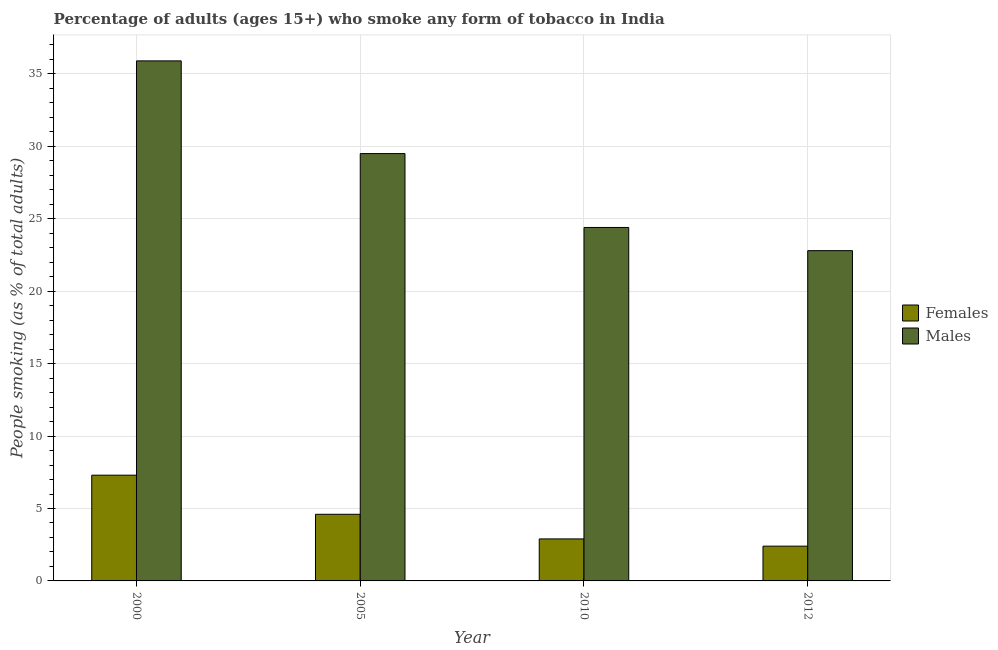How many bars are there on the 3rd tick from the left?
Make the answer very short. 2. In how many cases, is the number of bars for a given year not equal to the number of legend labels?
Offer a terse response. 0. What is the percentage of males who smoke in 2005?
Make the answer very short. 29.5. Across all years, what is the maximum percentage of males who smoke?
Provide a succinct answer. 35.9. Across all years, what is the minimum percentage of males who smoke?
Ensure brevity in your answer.  22.8. In which year was the percentage of males who smoke maximum?
Your answer should be very brief. 2000. What is the total percentage of females who smoke in the graph?
Your answer should be very brief. 17.2. What is the difference between the percentage of males who smoke in 2005 and the percentage of females who smoke in 2012?
Your response must be concise. 6.7. What is the average percentage of females who smoke per year?
Your answer should be compact. 4.3. In the year 2010, what is the difference between the percentage of females who smoke and percentage of males who smoke?
Provide a short and direct response. 0. What is the ratio of the percentage of females who smoke in 2000 to that in 2010?
Your answer should be compact. 2.52. Is the percentage of females who smoke in 2000 less than that in 2010?
Ensure brevity in your answer.  No. Is the difference between the percentage of males who smoke in 2005 and 2012 greater than the difference between the percentage of females who smoke in 2005 and 2012?
Offer a terse response. No. What is the difference between the highest and the second highest percentage of males who smoke?
Your response must be concise. 6.4. What is the difference between the highest and the lowest percentage of males who smoke?
Provide a short and direct response. 13.1. In how many years, is the percentage of females who smoke greater than the average percentage of females who smoke taken over all years?
Ensure brevity in your answer.  2. Is the sum of the percentage of males who smoke in 2000 and 2005 greater than the maximum percentage of females who smoke across all years?
Keep it short and to the point. Yes. What does the 1st bar from the left in 2005 represents?
Make the answer very short. Females. What does the 1st bar from the right in 2010 represents?
Your response must be concise. Males. How many bars are there?
Offer a very short reply. 8. Are the values on the major ticks of Y-axis written in scientific E-notation?
Provide a short and direct response. No. Where does the legend appear in the graph?
Keep it short and to the point. Center right. How many legend labels are there?
Offer a very short reply. 2. How are the legend labels stacked?
Provide a succinct answer. Vertical. What is the title of the graph?
Ensure brevity in your answer.  Percentage of adults (ages 15+) who smoke any form of tobacco in India. What is the label or title of the Y-axis?
Offer a terse response. People smoking (as % of total adults). What is the People smoking (as % of total adults) in Females in 2000?
Your answer should be very brief. 7.3. What is the People smoking (as % of total adults) in Males in 2000?
Make the answer very short. 35.9. What is the People smoking (as % of total adults) in Females in 2005?
Your answer should be very brief. 4.6. What is the People smoking (as % of total adults) of Males in 2005?
Provide a short and direct response. 29.5. What is the People smoking (as % of total adults) in Females in 2010?
Your answer should be very brief. 2.9. What is the People smoking (as % of total adults) in Males in 2010?
Give a very brief answer. 24.4. What is the People smoking (as % of total adults) in Males in 2012?
Your response must be concise. 22.8. Across all years, what is the maximum People smoking (as % of total adults) of Females?
Make the answer very short. 7.3. Across all years, what is the maximum People smoking (as % of total adults) of Males?
Keep it short and to the point. 35.9. Across all years, what is the minimum People smoking (as % of total adults) in Females?
Your answer should be compact. 2.4. Across all years, what is the minimum People smoking (as % of total adults) in Males?
Keep it short and to the point. 22.8. What is the total People smoking (as % of total adults) in Males in the graph?
Offer a terse response. 112.6. What is the difference between the People smoking (as % of total adults) in Females in 2000 and that in 2005?
Your response must be concise. 2.7. What is the difference between the People smoking (as % of total adults) of Males in 2000 and that in 2005?
Offer a very short reply. 6.4. What is the difference between the People smoking (as % of total adults) of Females in 2000 and that in 2010?
Ensure brevity in your answer.  4.4. What is the difference between the People smoking (as % of total adults) in Males in 2000 and that in 2010?
Your answer should be compact. 11.5. What is the difference between the People smoking (as % of total adults) of Females in 2000 and that in 2012?
Give a very brief answer. 4.9. What is the difference between the People smoking (as % of total adults) in Males in 2005 and that in 2012?
Your response must be concise. 6.7. What is the difference between the People smoking (as % of total adults) of Males in 2010 and that in 2012?
Give a very brief answer. 1.6. What is the difference between the People smoking (as % of total adults) of Females in 2000 and the People smoking (as % of total adults) of Males in 2005?
Keep it short and to the point. -22.2. What is the difference between the People smoking (as % of total adults) in Females in 2000 and the People smoking (as % of total adults) in Males in 2010?
Ensure brevity in your answer.  -17.1. What is the difference between the People smoking (as % of total adults) of Females in 2000 and the People smoking (as % of total adults) of Males in 2012?
Ensure brevity in your answer.  -15.5. What is the difference between the People smoking (as % of total adults) of Females in 2005 and the People smoking (as % of total adults) of Males in 2010?
Your answer should be very brief. -19.8. What is the difference between the People smoking (as % of total adults) of Females in 2005 and the People smoking (as % of total adults) of Males in 2012?
Your answer should be compact. -18.2. What is the difference between the People smoking (as % of total adults) in Females in 2010 and the People smoking (as % of total adults) in Males in 2012?
Your answer should be compact. -19.9. What is the average People smoking (as % of total adults) in Males per year?
Your answer should be compact. 28.15. In the year 2000, what is the difference between the People smoking (as % of total adults) in Females and People smoking (as % of total adults) in Males?
Give a very brief answer. -28.6. In the year 2005, what is the difference between the People smoking (as % of total adults) in Females and People smoking (as % of total adults) in Males?
Your answer should be compact. -24.9. In the year 2010, what is the difference between the People smoking (as % of total adults) of Females and People smoking (as % of total adults) of Males?
Ensure brevity in your answer.  -21.5. In the year 2012, what is the difference between the People smoking (as % of total adults) of Females and People smoking (as % of total adults) of Males?
Your answer should be compact. -20.4. What is the ratio of the People smoking (as % of total adults) in Females in 2000 to that in 2005?
Offer a terse response. 1.59. What is the ratio of the People smoking (as % of total adults) of Males in 2000 to that in 2005?
Offer a terse response. 1.22. What is the ratio of the People smoking (as % of total adults) in Females in 2000 to that in 2010?
Ensure brevity in your answer.  2.52. What is the ratio of the People smoking (as % of total adults) in Males in 2000 to that in 2010?
Offer a very short reply. 1.47. What is the ratio of the People smoking (as % of total adults) of Females in 2000 to that in 2012?
Keep it short and to the point. 3.04. What is the ratio of the People smoking (as % of total adults) in Males in 2000 to that in 2012?
Give a very brief answer. 1.57. What is the ratio of the People smoking (as % of total adults) of Females in 2005 to that in 2010?
Your answer should be very brief. 1.59. What is the ratio of the People smoking (as % of total adults) in Males in 2005 to that in 2010?
Give a very brief answer. 1.21. What is the ratio of the People smoking (as % of total adults) in Females in 2005 to that in 2012?
Ensure brevity in your answer.  1.92. What is the ratio of the People smoking (as % of total adults) in Males in 2005 to that in 2012?
Make the answer very short. 1.29. What is the ratio of the People smoking (as % of total adults) in Females in 2010 to that in 2012?
Make the answer very short. 1.21. What is the ratio of the People smoking (as % of total adults) in Males in 2010 to that in 2012?
Provide a short and direct response. 1.07. What is the difference between the highest and the second highest People smoking (as % of total adults) of Females?
Provide a succinct answer. 2.7. 